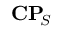<formula> <loc_0><loc_0><loc_500><loc_500>C P \, _ { S }</formula> 